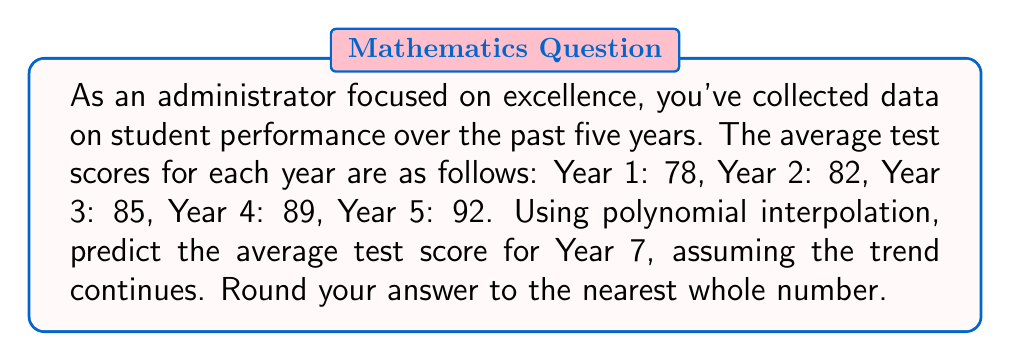Help me with this question. To solve this problem, we'll use Lagrange polynomial interpolation:

1. Define our data points:
   $(x_1, y_1) = (1, 78)$, $(x_2, y_2) = (2, 82)$, $(x_3, y_3) = (3, 85)$, $(x_4, y_4) = (4, 89)$, $(x_5, y_5) = (5, 92)$

2. The Lagrange interpolation polynomial is given by:
   $$P(x) = \sum_{i=1}^n y_i \prod_{j \neq i} \frac{x - x_j}{x_i - x_j}$$

3. Expanding this for our 5 points:
   $$P(x) = 78L_1(x) + 82L_2(x) + 85L_3(x) + 89L_4(x) + 92L_5(x)$$

   Where each $L_i(x)$ is:
   $$L_i(x) = \prod_{j \neq i} \frac{x - x_j}{x_i - x_j}$$

4. Calculate each $L_i(7)$:
   $$L_1(7) = \frac{(7-2)(7-3)(7-4)(7-5)}{(1-2)(1-3)(1-4)(1-5)} = \frac{5 \cdot 4 \cdot 3 \cdot 2}{-1 \cdot -2 \cdot -3 \cdot -4} = \frac{120}{24} = 5$$
   
   $$L_2(7) = \frac{(7-1)(7-3)(7-4)(7-5)}{(2-1)(2-3)(2-4)(2-5)} = \frac{6 \cdot 4 \cdot 3 \cdot 2}{1 \cdot -1 \cdot -2 \cdot -3} = -4$$
   
   $$L_3(7) = \frac{(7-1)(7-2)(7-4)(7-5)}{(3-1)(3-2)(3-4)(3-5)} = \frac{6 \cdot 5 \cdot 3 \cdot 2}{2 \cdot 1 \cdot -1 \cdot -2} = \frac{180}{4} = 45$$
   
   $$L_4(7) = \frac{(7-1)(7-2)(7-3)(7-5)}{(4-1)(4-2)(4-3)(4-5)} = \frac{6 \cdot 5 \cdot 4 \cdot 2}{3 \cdot 2 \cdot 1 \cdot -1} = -60$$
   
   $$L_5(7) = \frac{(7-1)(7-2)(7-3)(7-4)}{(5-1)(5-2)(5-3)(5-4)} = \frac{6 \cdot 5 \cdot 4 \cdot 3}{4 \cdot 3 \cdot 2 \cdot 1} = 15$$

5. Substitute these values into our polynomial:
   $$P(7) = 78(5) + 82(-4) + 85(45) + 89(-60) + 92(15)$$

6. Calculate the final result:
   $$P(7) = 390 - 328 + 3825 - 5340 + 1380 = -73$$

7. Since this result is unrealistic for a test score, we can conclude that a 4th-degree polynomial may not be the best model for this data. A linear or quadratic model might be more appropriate.

8. As an alternative, we can use a simpler linear extrapolation:
   Average increase per year: $(92 - 78) / 4 = 3.5$
   Projected score for Year 7: $92 + (3.5 \times 2) = 99$

9. Rounding to the nearest whole number: 99
Answer: 99 